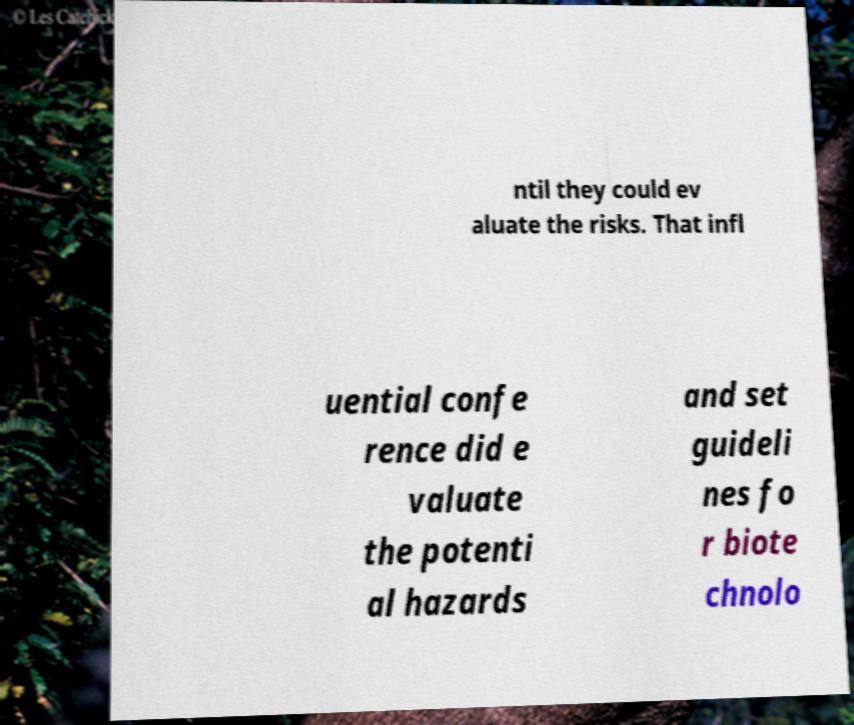Please read and relay the text visible in this image. What does it say? ntil they could ev aluate the risks. That infl uential confe rence did e valuate the potenti al hazards and set guideli nes fo r biote chnolo 